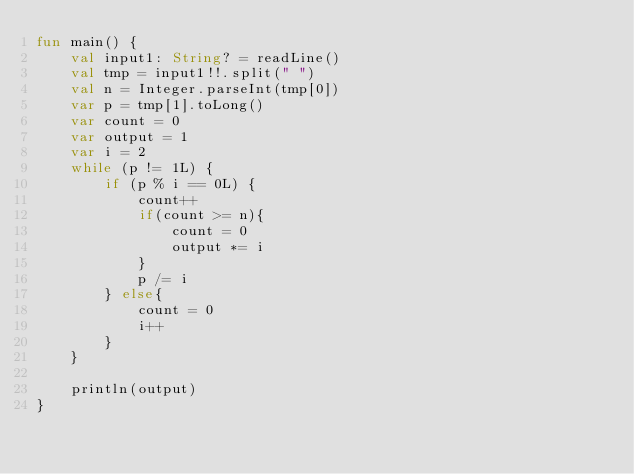<code> <loc_0><loc_0><loc_500><loc_500><_Kotlin_>fun main() {
    val input1: String? = readLine()
    val tmp = input1!!.split(" ")
    val n = Integer.parseInt(tmp[0])
    var p = tmp[1].toLong()
    var count = 0
    var output = 1
    var i = 2
    while (p != 1L) {
        if (p % i == 0L) {
            count++
            if(count >= n){
                count = 0
                output *= i
            }
            p /= i
        } else{
            count = 0
            i++
        }
    }

    println(output)
}</code> 